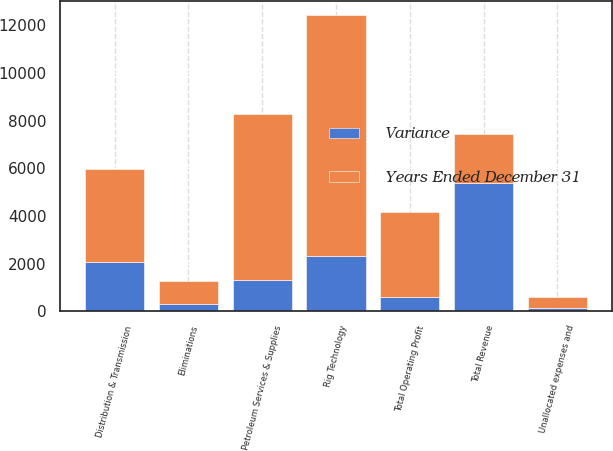Convert chart to OTSL. <chart><loc_0><loc_0><loc_500><loc_500><stacked_bar_chart><ecel><fcel>Rig Technology<fcel>Petroleum Services & Supplies<fcel>Distribution & Transmission<fcel>Eliminations<fcel>Total Revenue<fcel>Unallocated expenses and<fcel>Total Operating Profit<nl><fcel>Years Ended December 31<fcel>10107<fcel>6967<fcel>3927<fcel>960<fcel>2054<fcel>464<fcel>3557<nl><fcel>Variance<fcel>2319<fcel>1313<fcel>2054<fcel>303<fcel>5383<fcel>141<fcel>620<nl></chart> 